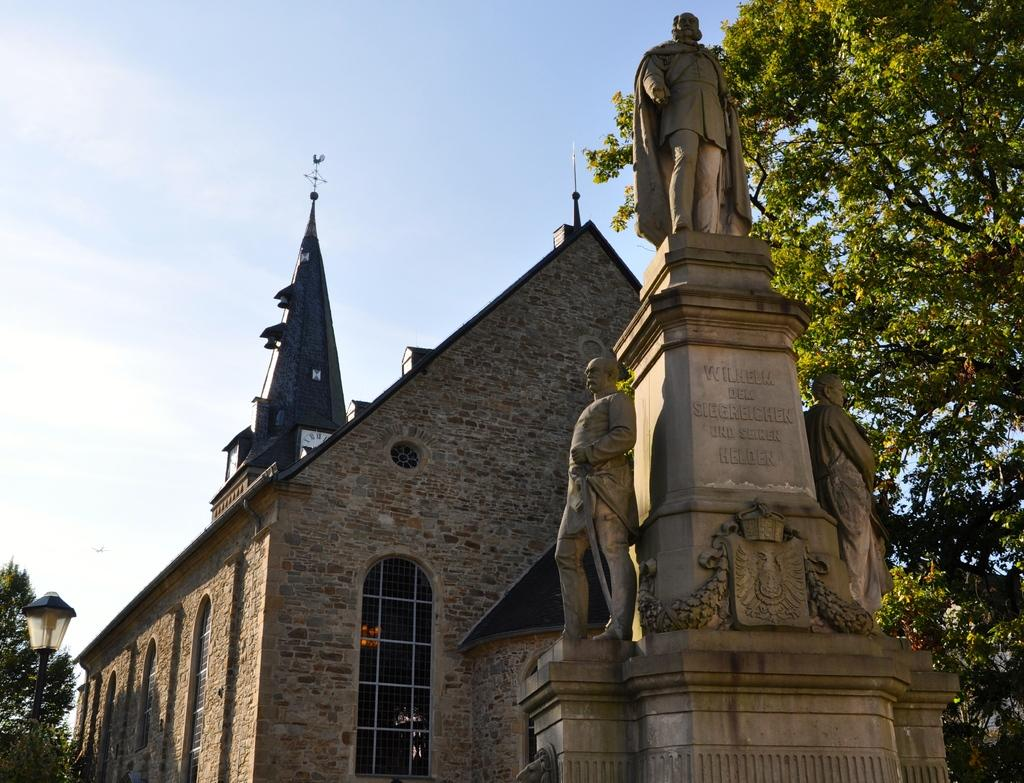What is visible at the top of the image? The sky is visible at the top of the image. What type of natural vegetation can be seen in the image? There are trees in the image. What type of artificial light source is present in the image? There is a light in the image. What type of architectural feature is present in the image? There are statues on a pedestal in the image. What type of structure is present in the image? There is a wall in the image. What type of opening is present in the wall? There is a window in the image. How many planes can be seen flying in the image? There are no planes visible in the image. What type of aunt is present in the image? There is no aunt present in the image. 